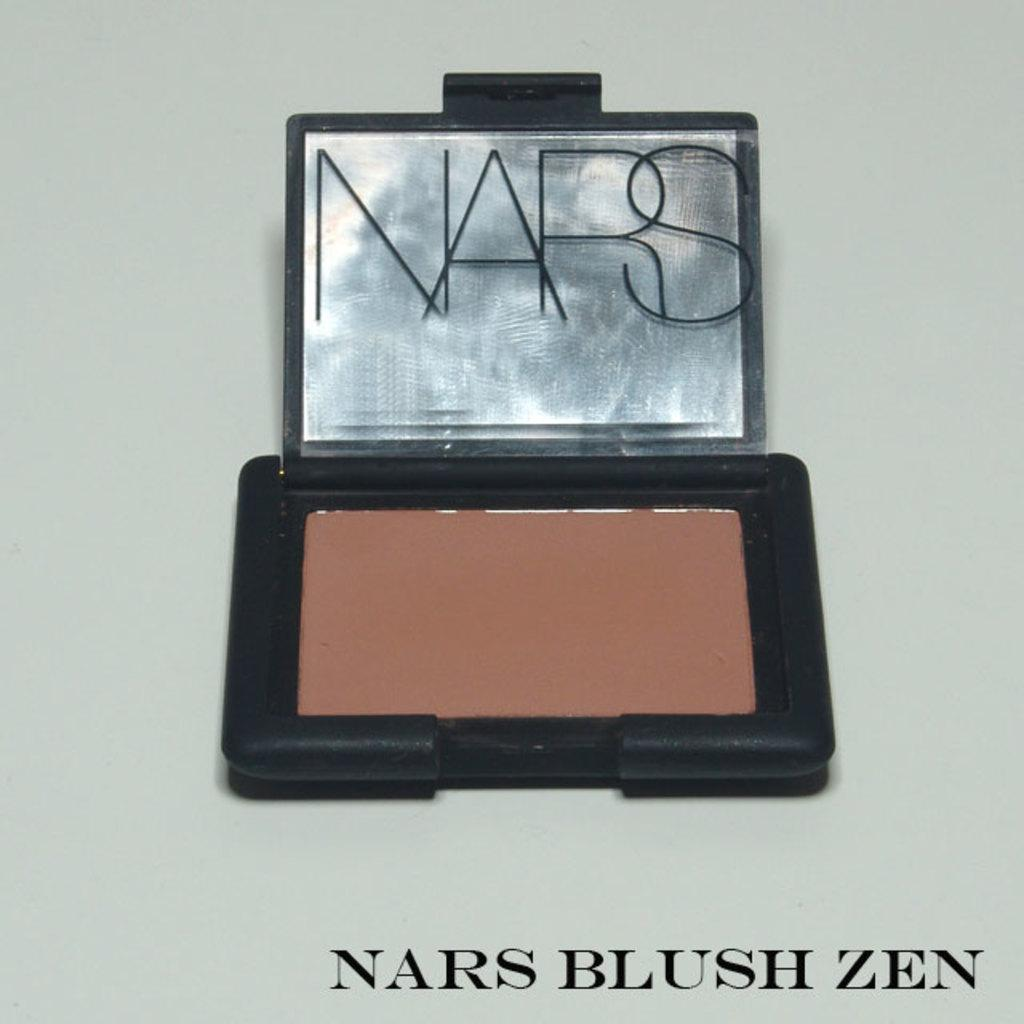<image>
Write a terse but informative summary of the picture. A blush kit made by the NARS company. 